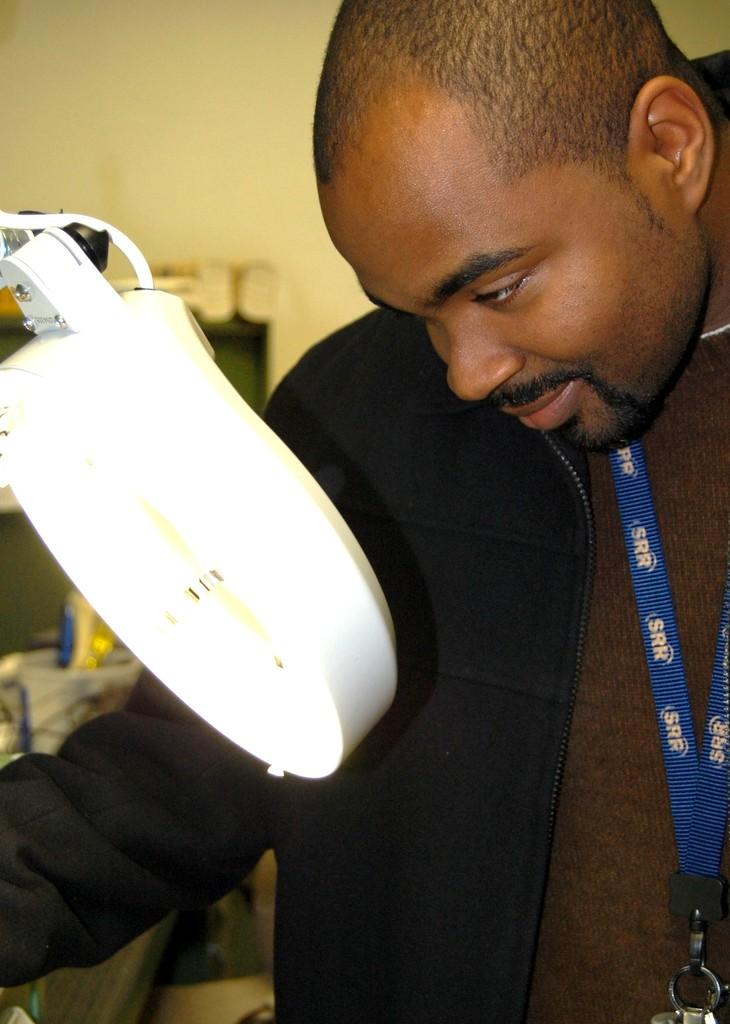Who is the person in the image? There is a man in the image. What is the man wearing? The man is wearing a black shirt. Where is the man positioned in the image? The man is standing in the front. What type of light can be seen in the image? There is a white table light in the image. What color is the wall in the background of the image? There is a yellow wall in the background of the image. What type of ice can be seen melting on the man's shirt in the image? There is no ice present in the image, and therefore no ice can be seen melting on the man's shirt. 